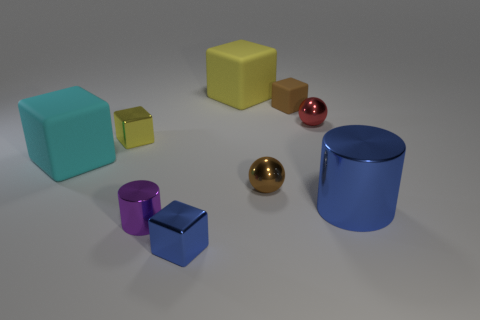Are there any big cyan blocks made of the same material as the purple cylinder?
Make the answer very short. No. What material is the cylinder that is the same size as the yellow rubber object?
Make the answer very short. Metal. There is a shiny sphere that is left of the tiny ball behind the large rubber object that is in front of the small yellow block; what size is it?
Your response must be concise. Small. Are there any tiny things left of the yellow cube in front of the red metallic thing?
Keep it short and to the point. No. There is a large yellow thing; is it the same shape as the small brown thing behind the small red thing?
Make the answer very short. Yes. There is a metal cylinder in front of the big blue thing; what is its color?
Offer a terse response. Purple. There is a metal ball on the right side of the brown object that is in front of the tiny matte block; how big is it?
Give a very brief answer. Small. Is the shape of the tiny brown thing in front of the red metal ball the same as  the yellow rubber object?
Offer a very short reply. No. There is another large object that is the same shape as the large cyan thing; what material is it?
Offer a very short reply. Rubber. What number of things are matte blocks that are on the left side of the yellow matte cube or blocks that are behind the red metal thing?
Your answer should be very brief. 3. 